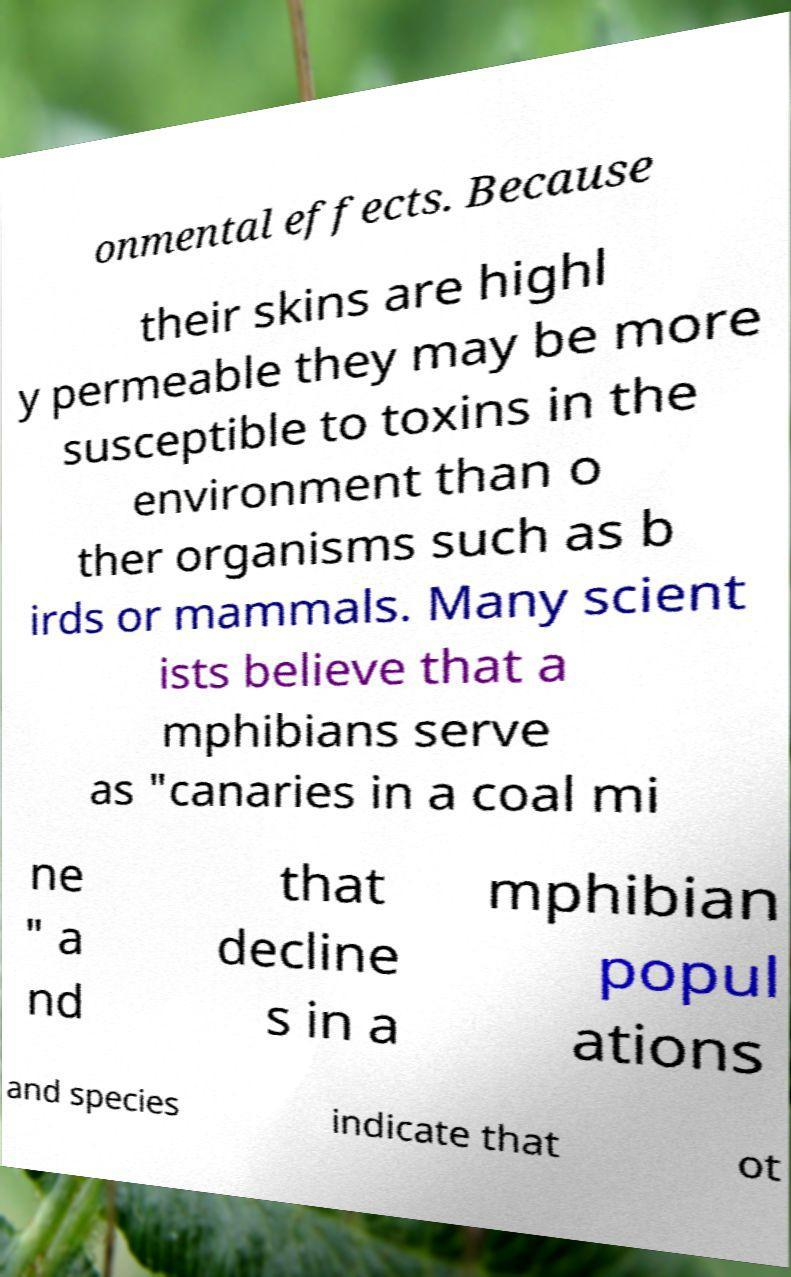There's text embedded in this image that I need extracted. Can you transcribe it verbatim? onmental effects. Because their skins are highl y permeable they may be more susceptible to toxins in the environment than o ther organisms such as b irds or mammals. Many scient ists believe that a mphibians serve as "canaries in a coal mi ne " a nd that decline s in a mphibian popul ations and species indicate that ot 